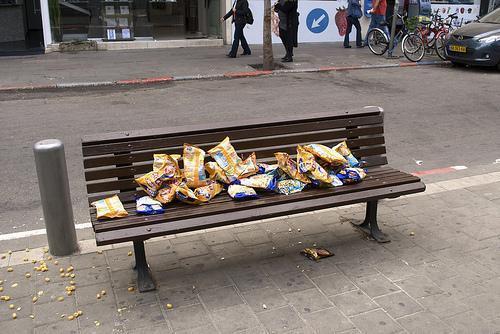How many people are in the photo?
Give a very brief answer. 4. 